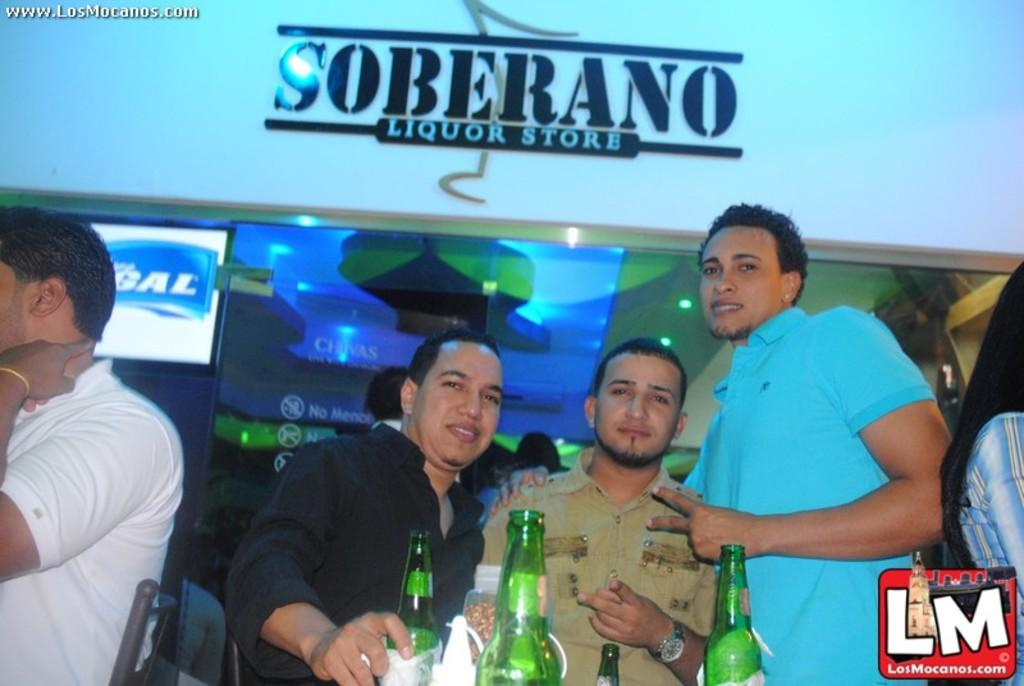<image>
Write a terse but informative summary of the picture. Three men are standing at Soberano Liquor Store. 